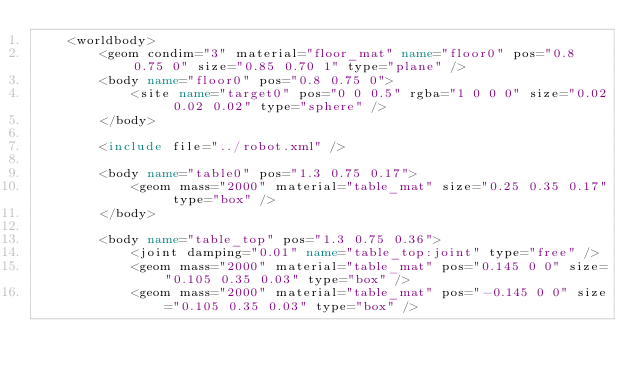Convert code to text. <code><loc_0><loc_0><loc_500><loc_500><_XML_>	<worldbody>
		<geom condim="3" material="floor_mat" name="floor0" pos="0.8 0.75 0" size="0.85 0.70 1" type="plane" />
		<body name="floor0" pos="0.8 0.75 0">
			<site name="target0" pos="0 0 0.5" rgba="1 0 0 0" size="0.02 0.02 0.02" type="sphere" />
		</body>

		<include file="../robot.xml" />

		<body name="table0" pos="1.3 0.75 0.17">
			<geom mass="2000" material="table_mat" size="0.25 0.35 0.17" type="box" />
		</body>

		<body name="table_top" pos="1.3 0.75 0.36">
			<joint damping="0.01" name="table_top:joint" type="free" />
			<geom mass="2000" material="table_mat" pos="0.145 0 0" size="0.105 0.35 0.03" type="box" />
			<geom mass="2000" material="table_mat" pos="-0.145 0 0" size="0.105 0.35 0.03" type="box" /></code> 